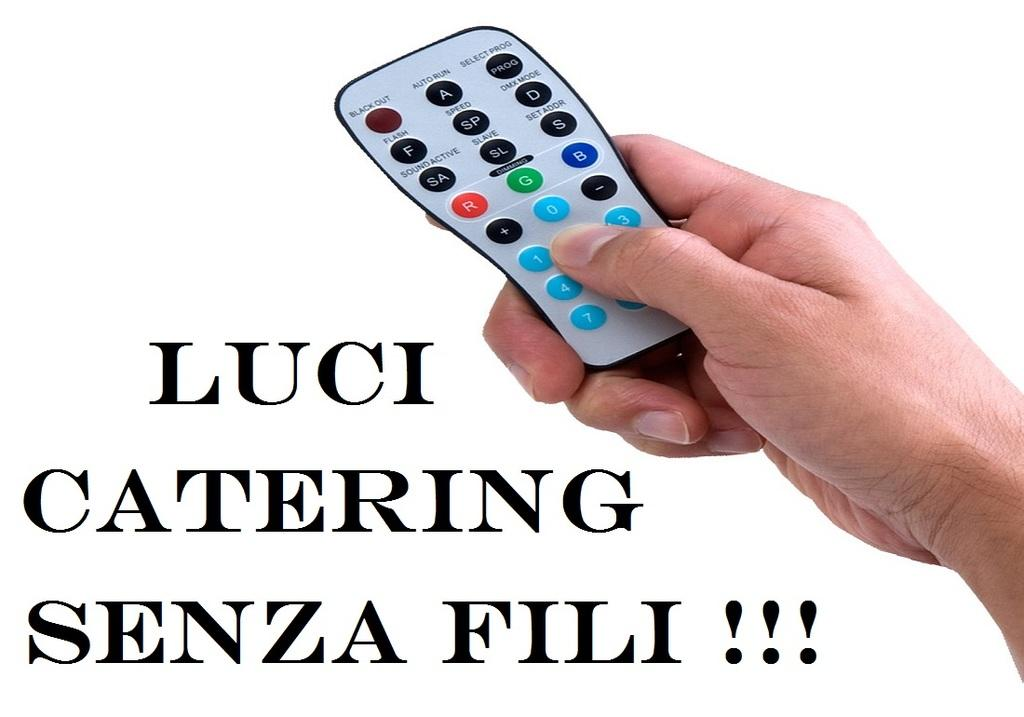<image>
Give a short and clear explanation of the subsequent image. a photo of a remote with the quote "Luci Catering Senza Fili!!!" 